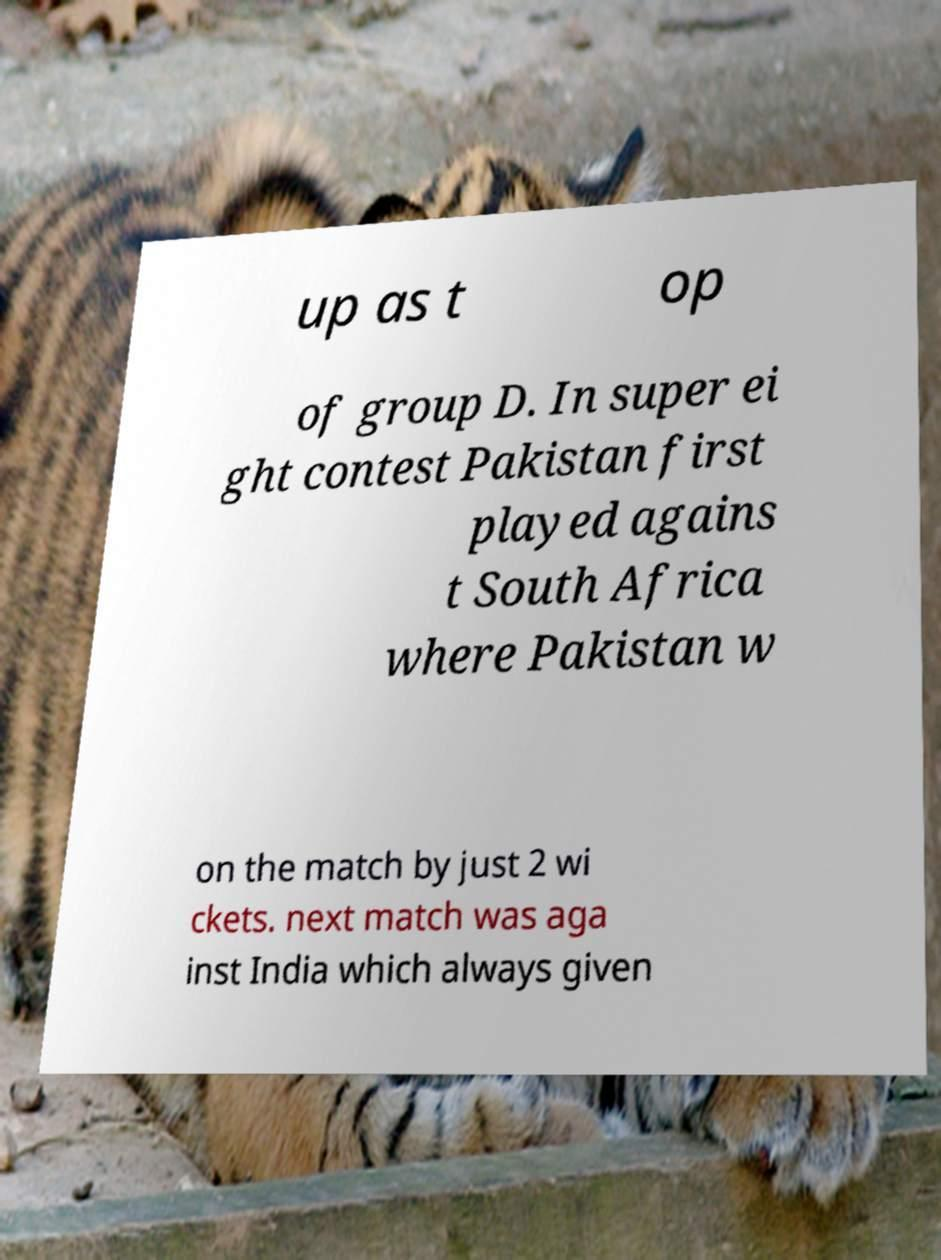Could you extract and type out the text from this image? up as t op of group D. In super ei ght contest Pakistan first played agains t South Africa where Pakistan w on the match by just 2 wi ckets. next match was aga inst India which always given 